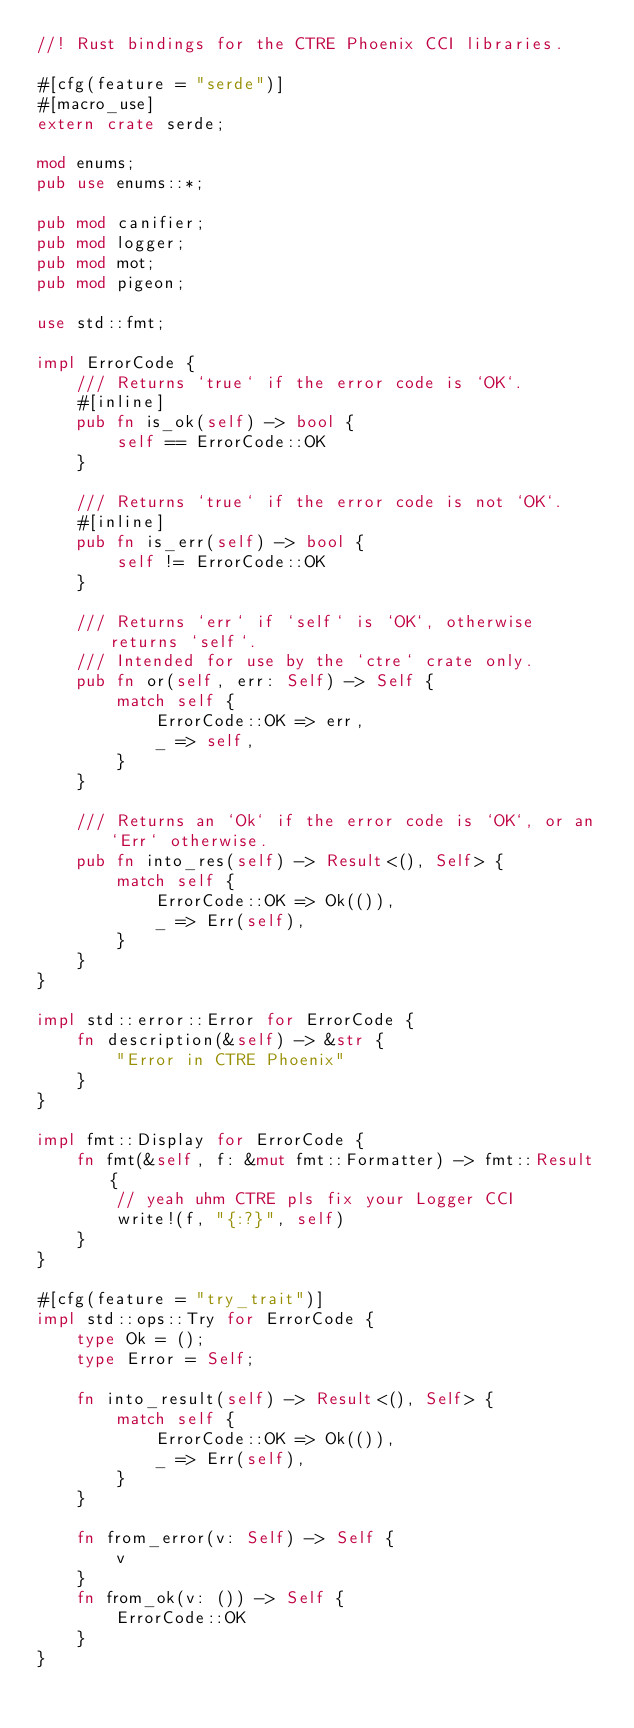Convert code to text. <code><loc_0><loc_0><loc_500><loc_500><_Rust_>//! Rust bindings for the CTRE Phoenix CCI libraries.

#[cfg(feature = "serde")]
#[macro_use]
extern crate serde;

mod enums;
pub use enums::*;

pub mod canifier;
pub mod logger;
pub mod mot;
pub mod pigeon;

use std::fmt;

impl ErrorCode {
    /// Returns `true` if the error code is `OK`.
    #[inline]
    pub fn is_ok(self) -> bool {
        self == ErrorCode::OK
    }

    /// Returns `true` if the error code is not `OK`.
    #[inline]
    pub fn is_err(self) -> bool {
        self != ErrorCode::OK
    }

    /// Returns `err` if `self` is `OK`, otherwise returns `self`.
    /// Intended for use by the `ctre` crate only.
    pub fn or(self, err: Self) -> Self {
        match self {
            ErrorCode::OK => err,
            _ => self,
        }
    }

    /// Returns an `Ok` if the error code is `OK`, or an `Err` otherwise.
    pub fn into_res(self) -> Result<(), Self> {
        match self {
            ErrorCode::OK => Ok(()),
            _ => Err(self),
        }
    }
}

impl std::error::Error for ErrorCode {
    fn description(&self) -> &str {
        "Error in CTRE Phoenix"
    }
}

impl fmt::Display for ErrorCode {
    fn fmt(&self, f: &mut fmt::Formatter) -> fmt::Result {
        // yeah uhm CTRE pls fix your Logger CCI
        write!(f, "{:?}", self)
    }
}

#[cfg(feature = "try_trait")]
impl std::ops::Try for ErrorCode {
    type Ok = ();
    type Error = Self;

    fn into_result(self) -> Result<(), Self> {
        match self {
            ErrorCode::OK => Ok(()),
            _ => Err(self),
        }
    }

    fn from_error(v: Self) -> Self {
        v
    }
    fn from_ok(v: ()) -> Self {
        ErrorCode::OK
    }
}
</code> 